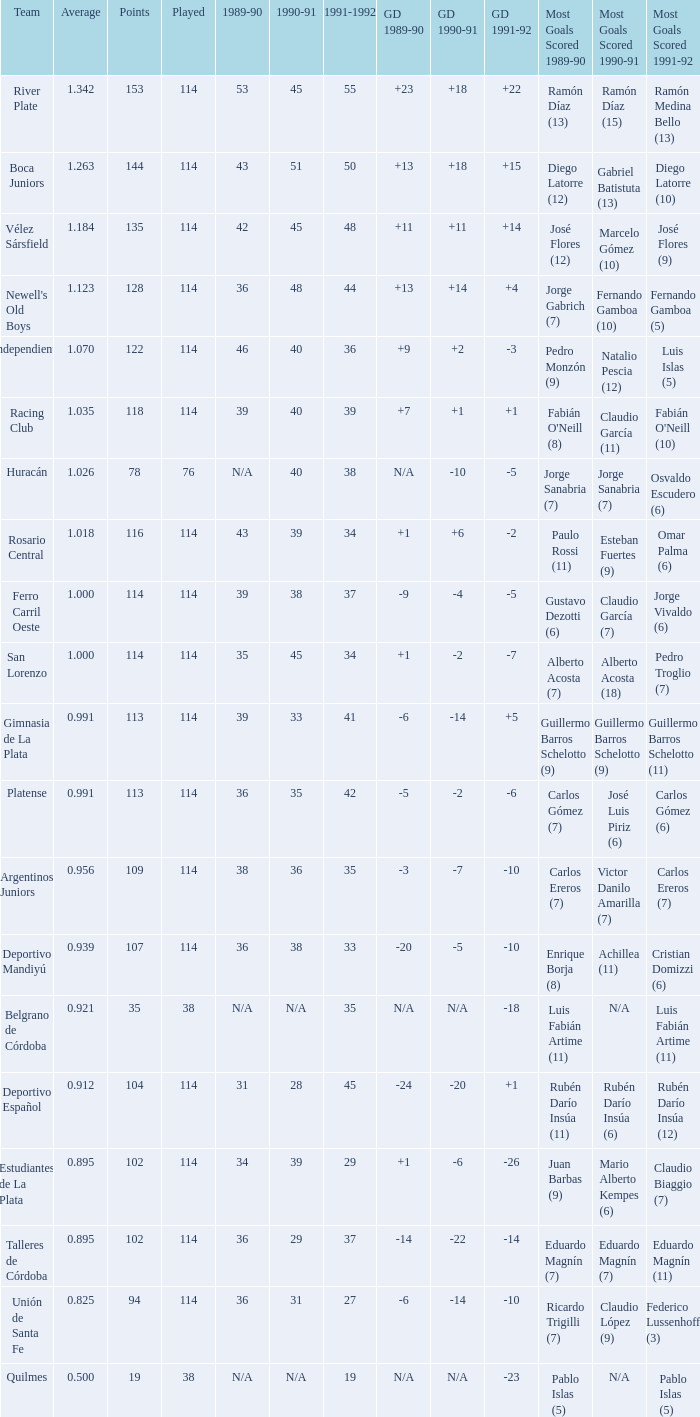How much Average has a 1989-90 of 36, and a Team of talleres de córdoba, and a Played smaller than 114? 0.0. 